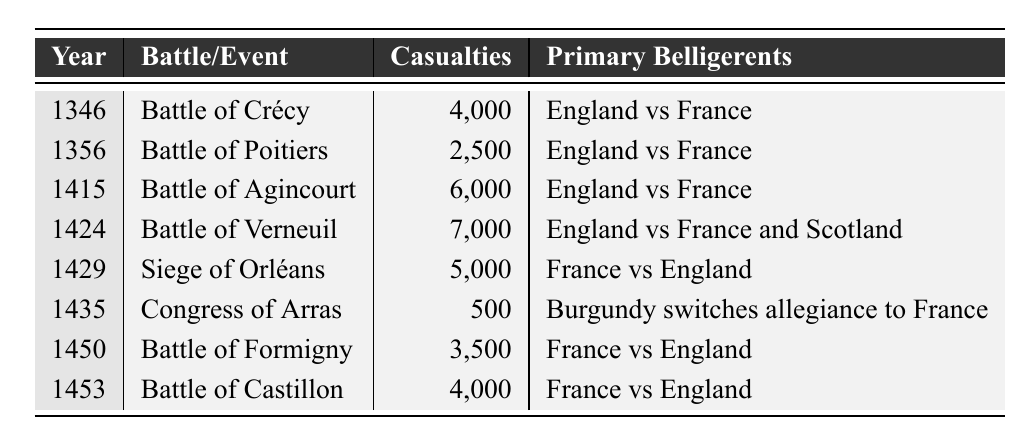What year did the Battle of Agincourt occur? The table shows that the Battle of Agincourt took place in the year 1415.
Answer: 1415 Which event had the highest number of casualties? The highest number of casualties in the table is from the Battle of Verneuil in 1424, with 7,000 casualties.
Answer: Battle of Verneuil How many total casualties were recorded across all events? To find the total casualties, sum all the casualties: 4000 + 2500 + 6000 + 7000 + 5000 + 500 + 3500 + 4000 = 25,500.
Answer: 25,500 Did the casualties increase from the Battle of Poitiers (1356) to the Battle of Agincourt (1415)? The casualties at Poitiers were 2,500, while at Agincourt they were 6,000, indicating an increase of 3,500 casualties.
Answer: Yes What was the average number of casualties for the battles listed? To find the average, sum all casualties (25,500) and divide by the number of events (8): 25,500 / 8 = 3,187.5.
Answer: 3,187.5 Which event had the least casualties, and how many were there? The Congress of Arras in 1435 had the least casualties recorded, with only 500.
Answer: 500 Was the Battle of Crécy fought after the Congress of Arras? The Battle of Crécy occurred in 1346, which is before the Congress of Arras in 1435, making this statement false.
Answer: No How many events resulted in at least 5,000 casualties? The events that had at least 5,000 casualties are the Battle of Verneuil, the Siege of Orléans, and the Battle of Agincourt, totaling three events.
Answer: 3 What was the change in casualties from the Battle of Formigny (1450) to the Battle of Castillon (1453)? The Battle of Formigny had 3,500 casualties and the Battle of Castillon had 4,000 casualties, representing an increase of 500 casualties.
Answer: Increase of 500 Did any battles involve alliances with Scotland? The Battle of Verneuil in 1424 involved England, France, and Scotland, indicating an alliance with Scotland.
Answer: Yes 